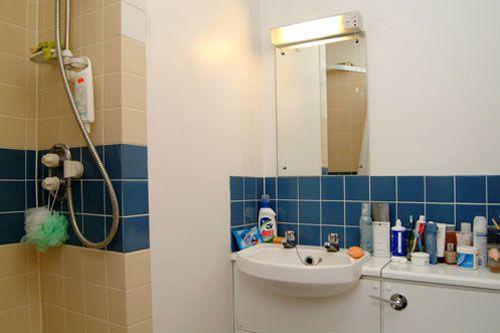Are all the tiles the same color?
Quick response, please. No. What room is this?
Answer briefly. Bathroom. Is the shower head removable?
Keep it brief. Yes. 